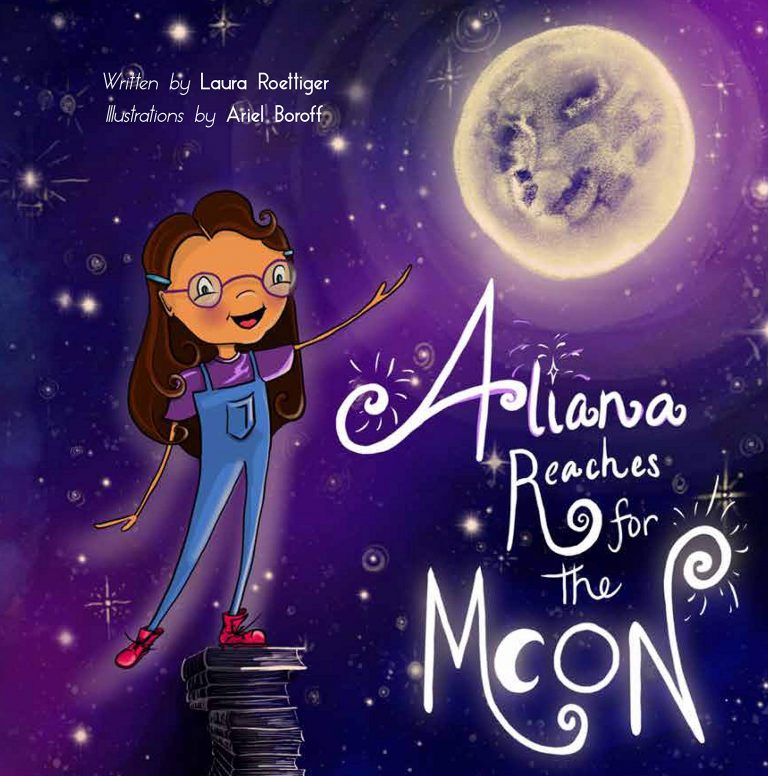If you could add another element to this illustration, what would it be and why? If I could add another element to this illustration, it would be a trail of stardust emanating from Aliana’s hand as she reaches toward the moon. This trail would symbolize the impact of her dreams and efforts, lighting up the path between her foundation of knowledge and her celestial goal. The stardust could also represent the smaller milestones and achievements she makes on her journey. Adding this element would visually capture the idea that each step of the journey toward achieving dreams leaves a mark and lights the way for future exploration. 